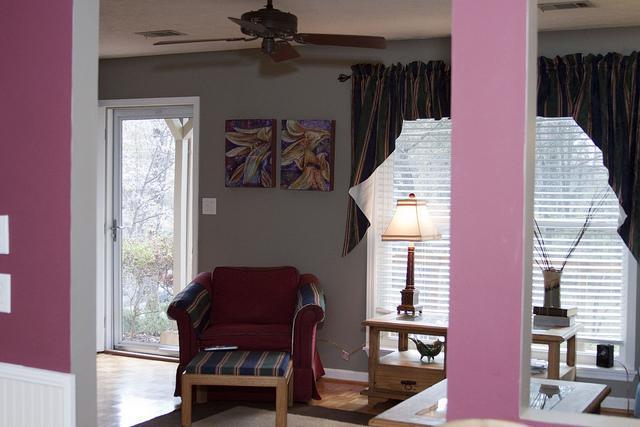How many food poles for the giraffes are there?
Give a very brief answer. 0. 